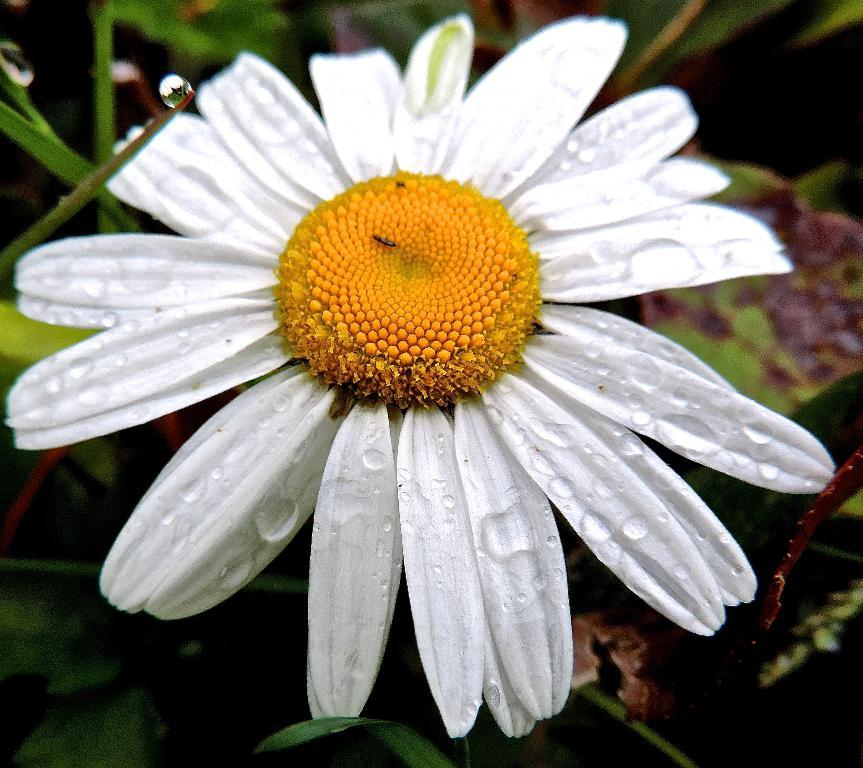What type of flower is in the image? There is a yellow and white flower in the image. What color are the leaves in the background of the image? The leaves in the background of the image are green. How would you describe the overall focus of the image? The image is slightly blurry in the background, indicating that the focus is on the flower in the foreground. What is the tendency of the flower to move in the image? The flower does not move in the image; it is a still photograph. 